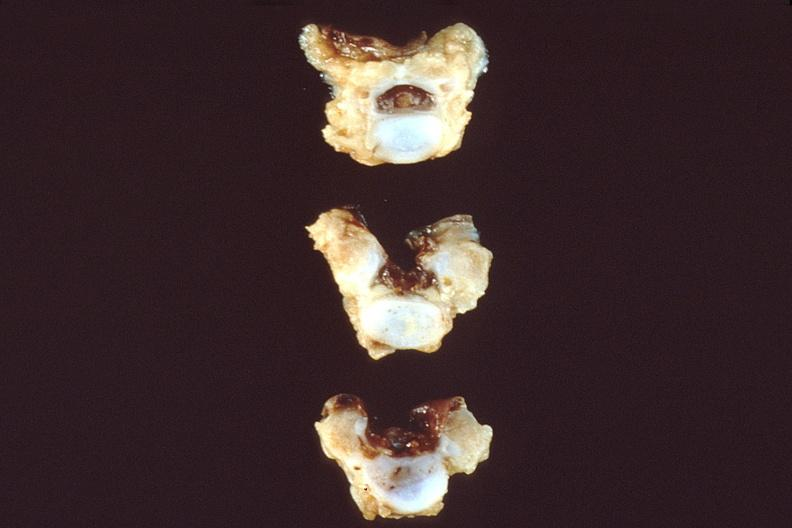does this photo show neural tube defect, vertebral bodies?
Answer the question using a single word or phrase. No 